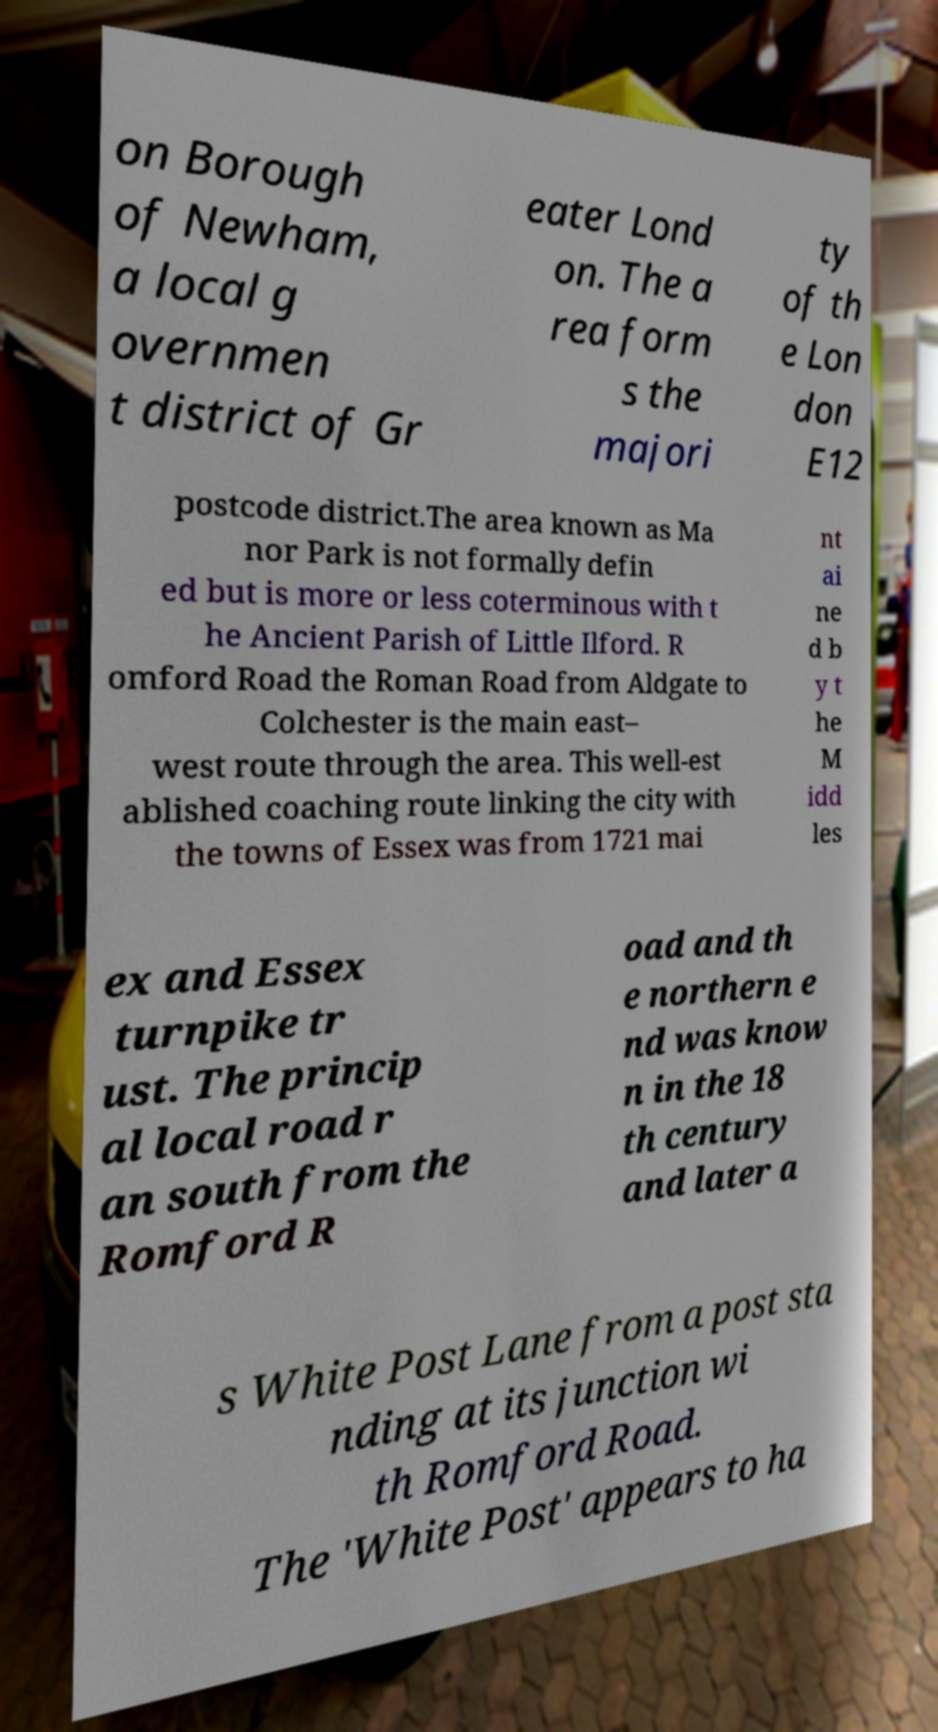Can you read and provide the text displayed in the image?This photo seems to have some interesting text. Can you extract and type it out for me? on Borough of Newham, a local g overnmen t district of Gr eater Lond on. The a rea form s the majori ty of th e Lon don E12 postcode district.The area known as Ma nor Park is not formally defin ed but is more or less coterminous with t he Ancient Parish of Little Ilford. R omford Road the Roman Road from Aldgate to Colchester is the main east– west route through the area. This well-est ablished coaching route linking the city with the towns of Essex was from 1721 mai nt ai ne d b y t he M idd les ex and Essex turnpike tr ust. The princip al local road r an south from the Romford R oad and th e northern e nd was know n in the 18 th century and later a s White Post Lane from a post sta nding at its junction wi th Romford Road. The 'White Post' appears to ha 